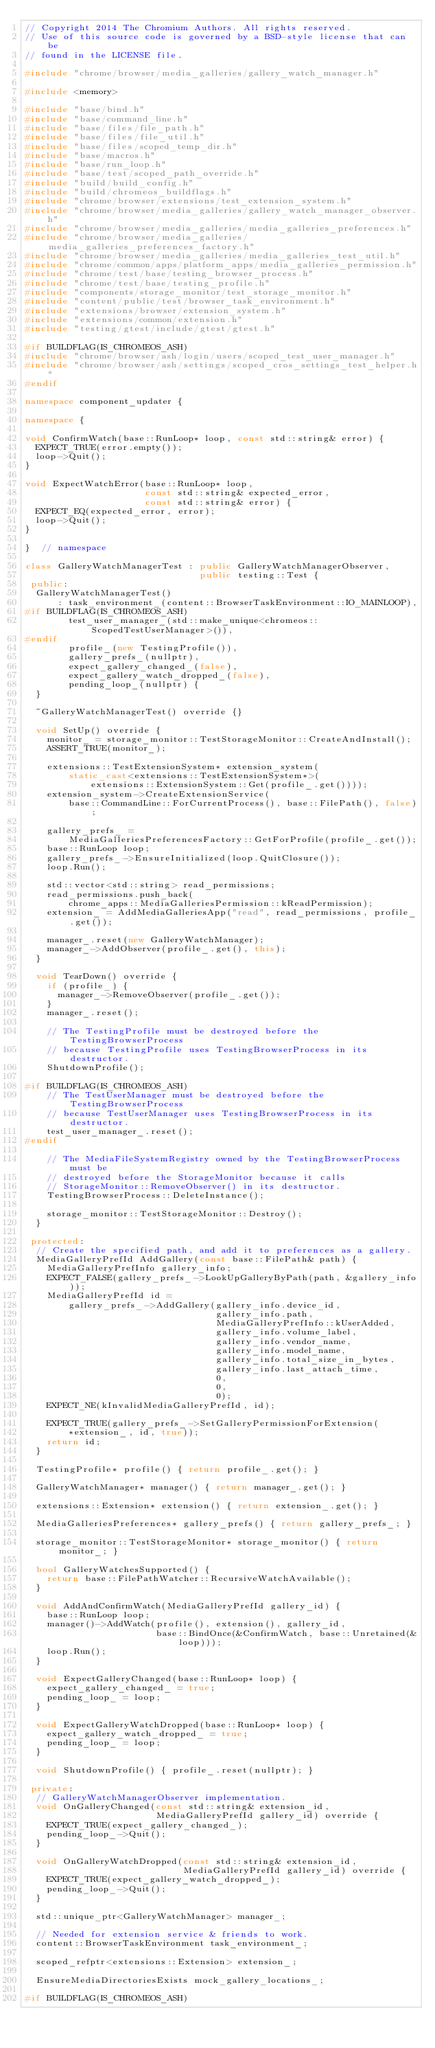Convert code to text. <code><loc_0><loc_0><loc_500><loc_500><_C++_>// Copyright 2014 The Chromium Authors. All rights reserved.
// Use of this source code is governed by a BSD-style license that can be
// found in the LICENSE file.

#include "chrome/browser/media_galleries/gallery_watch_manager.h"

#include <memory>

#include "base/bind.h"
#include "base/command_line.h"
#include "base/files/file_path.h"
#include "base/files/file_util.h"
#include "base/files/scoped_temp_dir.h"
#include "base/macros.h"
#include "base/run_loop.h"
#include "base/test/scoped_path_override.h"
#include "build/build_config.h"
#include "build/chromeos_buildflags.h"
#include "chrome/browser/extensions/test_extension_system.h"
#include "chrome/browser/media_galleries/gallery_watch_manager_observer.h"
#include "chrome/browser/media_galleries/media_galleries_preferences.h"
#include "chrome/browser/media_galleries/media_galleries_preferences_factory.h"
#include "chrome/browser/media_galleries/media_galleries_test_util.h"
#include "chrome/common/apps/platform_apps/media_galleries_permission.h"
#include "chrome/test/base/testing_browser_process.h"
#include "chrome/test/base/testing_profile.h"
#include "components/storage_monitor/test_storage_monitor.h"
#include "content/public/test/browser_task_environment.h"
#include "extensions/browser/extension_system.h"
#include "extensions/common/extension.h"
#include "testing/gtest/include/gtest/gtest.h"

#if BUILDFLAG(IS_CHROMEOS_ASH)
#include "chrome/browser/ash/login/users/scoped_test_user_manager.h"
#include "chrome/browser/ash/settings/scoped_cros_settings_test_helper.h"
#endif

namespace component_updater {

namespace {

void ConfirmWatch(base::RunLoop* loop, const std::string& error) {
  EXPECT_TRUE(error.empty());
  loop->Quit();
}

void ExpectWatchError(base::RunLoop* loop,
                      const std::string& expected_error,
                      const std::string& error) {
  EXPECT_EQ(expected_error, error);
  loop->Quit();
}

}  // namespace

class GalleryWatchManagerTest : public GalleryWatchManagerObserver,
                                public testing::Test {
 public:
  GalleryWatchManagerTest()
      : task_environment_(content::BrowserTaskEnvironment::IO_MAINLOOP),
#if BUILDFLAG(IS_CHROMEOS_ASH)
        test_user_manager_(std::make_unique<chromeos::ScopedTestUserManager>()),
#endif
        profile_(new TestingProfile()),
        gallery_prefs_(nullptr),
        expect_gallery_changed_(false),
        expect_gallery_watch_dropped_(false),
        pending_loop_(nullptr) {
  }

  ~GalleryWatchManagerTest() override {}

  void SetUp() override {
    monitor_ = storage_monitor::TestStorageMonitor::CreateAndInstall();
    ASSERT_TRUE(monitor_);

    extensions::TestExtensionSystem* extension_system(
        static_cast<extensions::TestExtensionSystem*>(
            extensions::ExtensionSystem::Get(profile_.get())));
    extension_system->CreateExtensionService(
        base::CommandLine::ForCurrentProcess(), base::FilePath(), false);

    gallery_prefs_ =
        MediaGalleriesPreferencesFactory::GetForProfile(profile_.get());
    base::RunLoop loop;
    gallery_prefs_->EnsureInitialized(loop.QuitClosure());
    loop.Run();

    std::vector<std::string> read_permissions;
    read_permissions.push_back(
        chrome_apps::MediaGalleriesPermission::kReadPermission);
    extension_ = AddMediaGalleriesApp("read", read_permissions, profile_.get());

    manager_.reset(new GalleryWatchManager);
    manager_->AddObserver(profile_.get(), this);
  }

  void TearDown() override {
    if (profile_) {
      manager_->RemoveObserver(profile_.get());
    }
    manager_.reset();

    // The TestingProfile must be destroyed before the TestingBrowserProcess
    // because TestingProfile uses TestingBrowserProcess in its destructor.
    ShutdownProfile();

#if BUILDFLAG(IS_CHROMEOS_ASH)
    // The TestUserManager must be destroyed before the TestingBrowserProcess
    // because TestUserManager uses TestingBrowserProcess in its destructor.
    test_user_manager_.reset();
#endif

    // The MediaFileSystemRegistry owned by the TestingBrowserProcess must be
    // destroyed before the StorageMonitor because it calls
    // StorageMonitor::RemoveObserver() in its destructor.
    TestingBrowserProcess::DeleteInstance();

    storage_monitor::TestStorageMonitor::Destroy();
  }

 protected:
  // Create the specified path, and add it to preferences as a gallery.
  MediaGalleryPrefId AddGallery(const base::FilePath& path) {
    MediaGalleryPrefInfo gallery_info;
    EXPECT_FALSE(gallery_prefs_->LookUpGalleryByPath(path, &gallery_info));
    MediaGalleryPrefId id =
        gallery_prefs_->AddGallery(gallery_info.device_id,
                                   gallery_info.path,
                                   MediaGalleryPrefInfo::kUserAdded,
                                   gallery_info.volume_label,
                                   gallery_info.vendor_name,
                                   gallery_info.model_name,
                                   gallery_info.total_size_in_bytes,
                                   gallery_info.last_attach_time,
                                   0,
                                   0,
                                   0);
    EXPECT_NE(kInvalidMediaGalleryPrefId, id);

    EXPECT_TRUE(gallery_prefs_->SetGalleryPermissionForExtension(
        *extension_, id, true));
    return id;
  }

  TestingProfile* profile() { return profile_.get(); }

  GalleryWatchManager* manager() { return manager_.get(); }

  extensions::Extension* extension() { return extension_.get(); }

  MediaGalleriesPreferences* gallery_prefs() { return gallery_prefs_; }

  storage_monitor::TestStorageMonitor* storage_monitor() { return monitor_; }

  bool GalleryWatchesSupported() {
    return base::FilePathWatcher::RecursiveWatchAvailable();
  }

  void AddAndConfirmWatch(MediaGalleryPrefId gallery_id) {
    base::RunLoop loop;
    manager()->AddWatch(profile(), extension(), gallery_id,
                        base::BindOnce(&ConfirmWatch, base::Unretained(&loop)));
    loop.Run();
  }

  void ExpectGalleryChanged(base::RunLoop* loop) {
    expect_gallery_changed_ = true;
    pending_loop_ = loop;
  }

  void ExpectGalleryWatchDropped(base::RunLoop* loop) {
    expect_gallery_watch_dropped_ = true;
    pending_loop_ = loop;
  }

  void ShutdownProfile() { profile_.reset(nullptr); }

 private:
  // GalleryWatchManagerObserver implementation.
  void OnGalleryChanged(const std::string& extension_id,
                        MediaGalleryPrefId gallery_id) override {
    EXPECT_TRUE(expect_gallery_changed_);
    pending_loop_->Quit();
  }

  void OnGalleryWatchDropped(const std::string& extension_id,
                             MediaGalleryPrefId gallery_id) override {
    EXPECT_TRUE(expect_gallery_watch_dropped_);
    pending_loop_->Quit();
  }

  std::unique_ptr<GalleryWatchManager> manager_;

  // Needed for extension service & friends to work.
  content::BrowserTaskEnvironment task_environment_;

  scoped_refptr<extensions::Extension> extension_;

  EnsureMediaDirectoriesExists mock_gallery_locations_;

#if BUILDFLAG(IS_CHROMEOS_ASH)</code> 